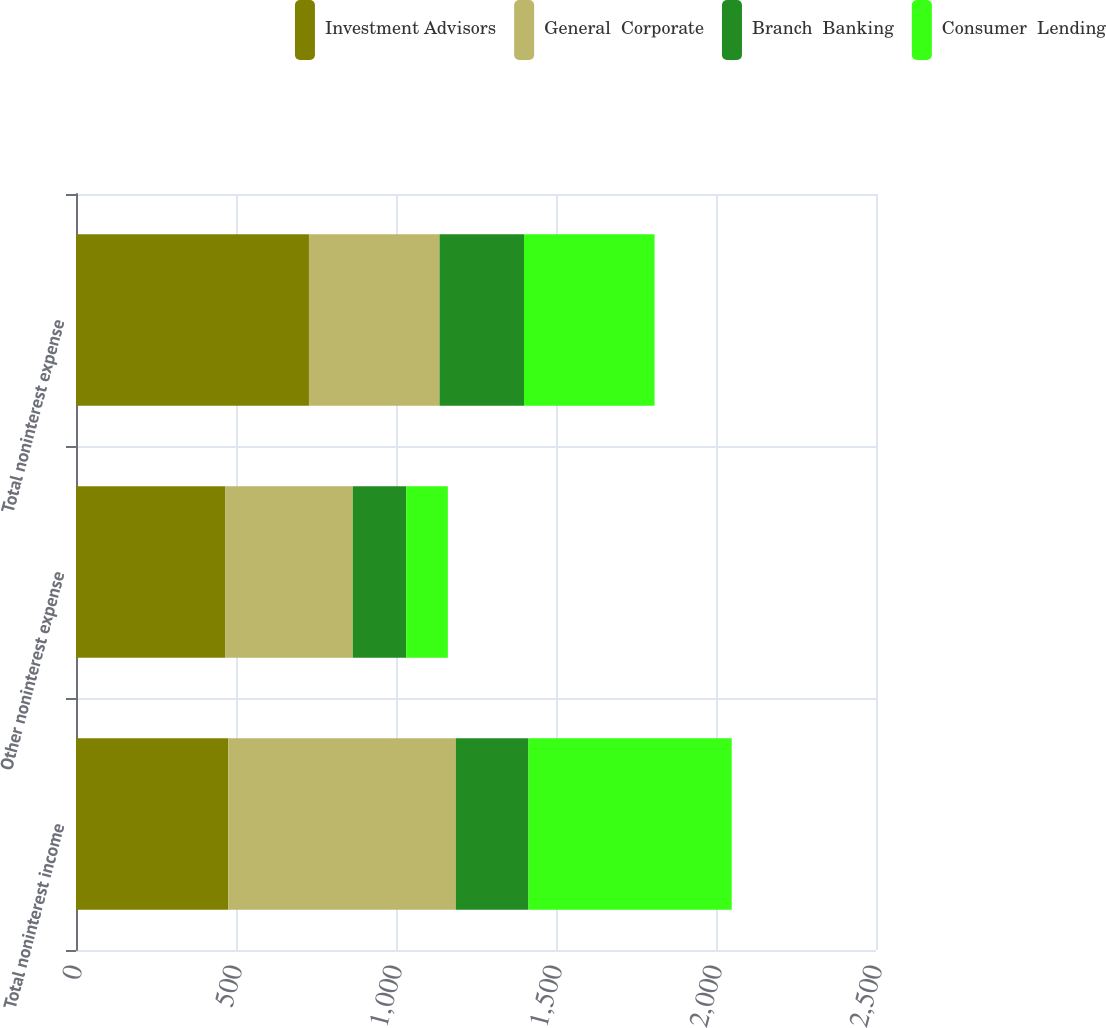Convert chart. <chart><loc_0><loc_0><loc_500><loc_500><stacked_bar_chart><ecel><fcel>Total noninterest income<fcel>Other noninterest expense<fcel>Total noninterest expense<nl><fcel>Investment Advisors<fcel>476<fcel>467<fcel>728<nl><fcel>General  Corporate<fcel>711<fcel>398<fcel>408<nl><fcel>Branch  Banking<fcel>227<fcel>167<fcel>264<nl><fcel>Consumer  Lending<fcel>635<fcel>130<fcel>408<nl></chart> 